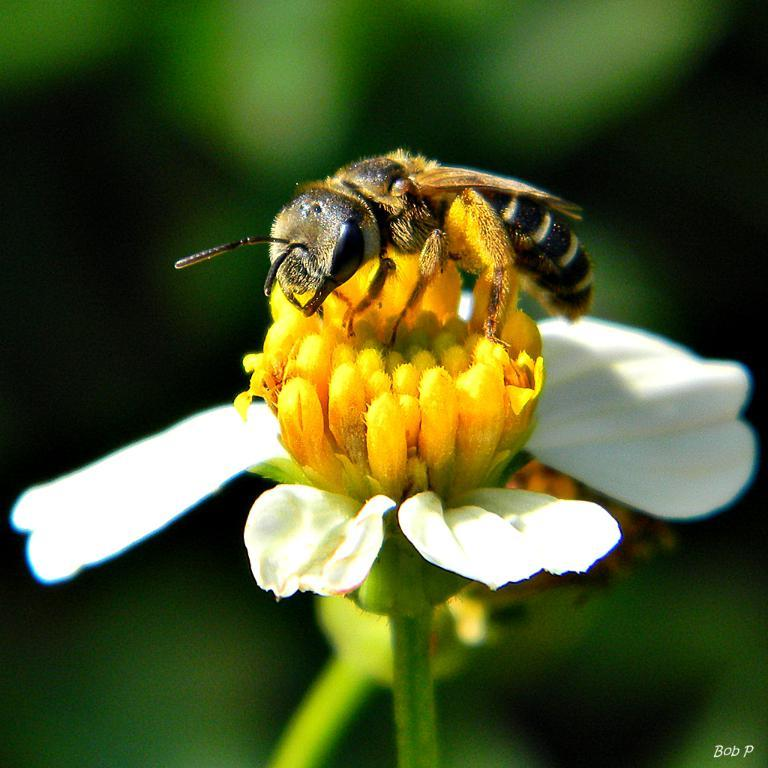What is on the flower in the image? There is an insect on the flower in the image. What color are the petals of the flower? The flower has white petals. Can you describe the background of the image? The background of the image is blurry. How many pages of a book can be seen in the image? There are no pages of a book present in the image. Are there any babies visible in the image? There are no babies visible in the image. 